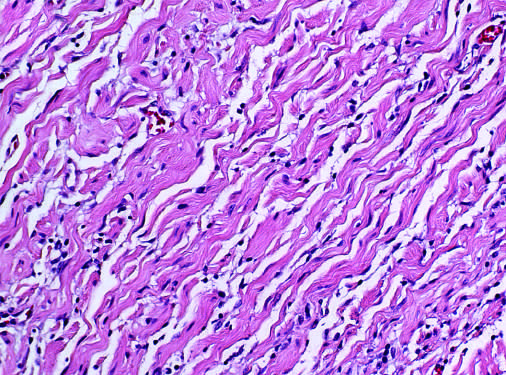what are bland spindle cells seen admixed with?
Answer the question using a single word or phrase. Collagen bundles 